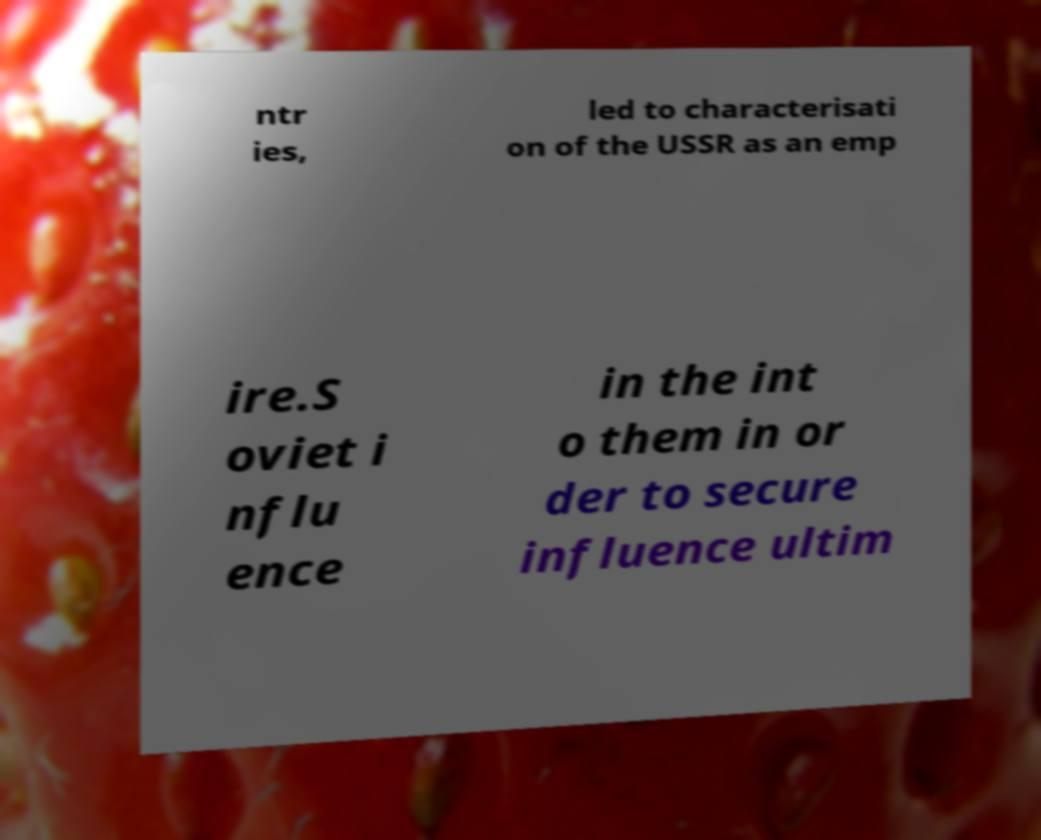Can you read and provide the text displayed in the image?This photo seems to have some interesting text. Can you extract and type it out for me? ntr ies, led to characterisati on of the USSR as an emp ire.S oviet i nflu ence in the int o them in or der to secure influence ultim 